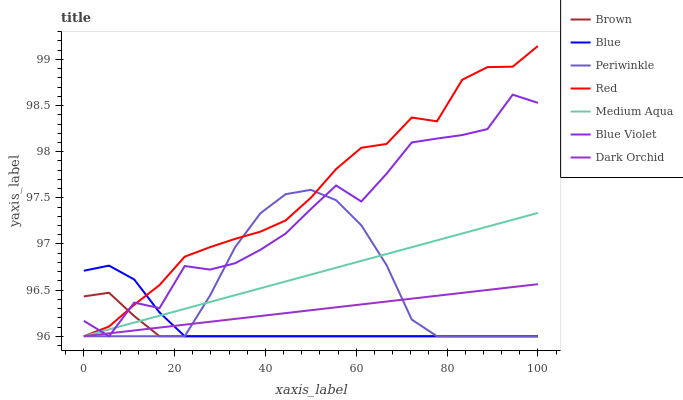Does Dark Orchid have the minimum area under the curve?
Answer yes or no. No. Does Dark Orchid have the maximum area under the curve?
Answer yes or no. No. Is Brown the smoothest?
Answer yes or no. No. Is Brown the roughest?
Answer yes or no. No. Does Dark Orchid have the highest value?
Answer yes or no. No. 